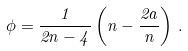Convert formula to latex. <formula><loc_0><loc_0><loc_500><loc_500>\phi = \frac { 1 } { 2 n - 4 } \left ( n - \frac { 2 a } { n } \right ) \, .</formula> 